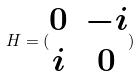<formula> <loc_0><loc_0><loc_500><loc_500>H = ( \begin{matrix} 0 & - i \\ i & 0 \end{matrix} )</formula> 